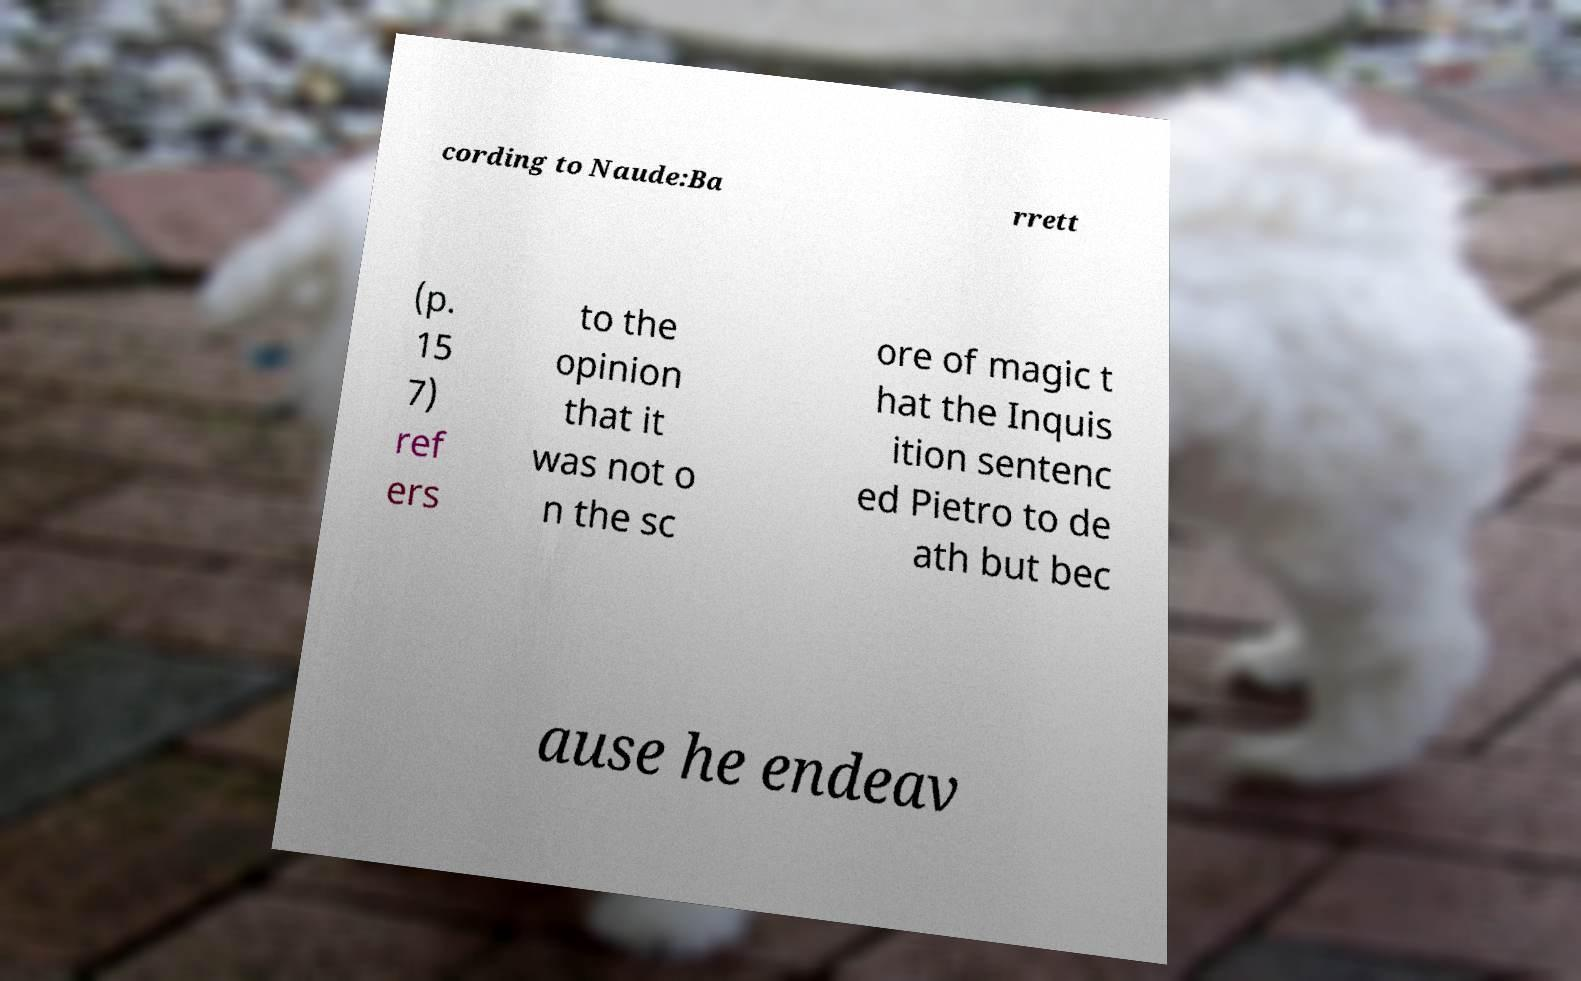What messages or text are displayed in this image? I need them in a readable, typed format. cording to Naude:Ba rrett (p. 15 7) ref ers to the opinion that it was not o n the sc ore of magic t hat the Inquis ition sentenc ed Pietro to de ath but bec ause he endeav 